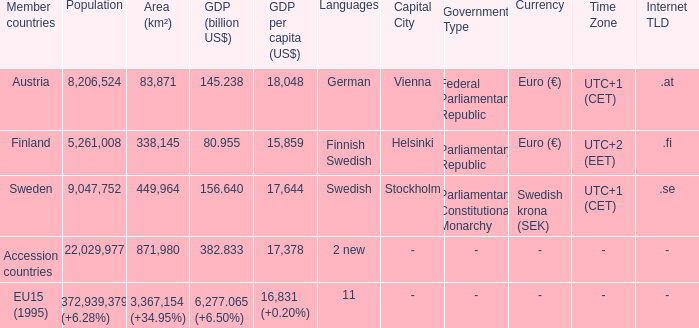Name the area for german 83871.0. 